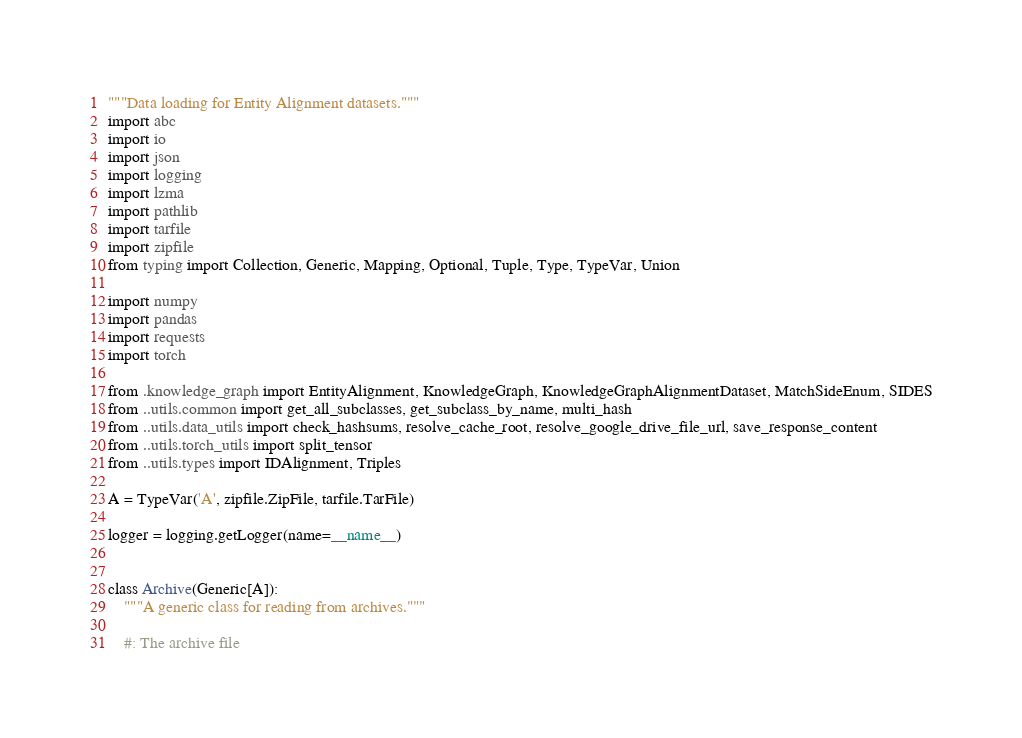Convert code to text. <code><loc_0><loc_0><loc_500><loc_500><_Python_>"""Data loading for Entity Alignment datasets."""
import abc
import io
import json
import logging
import lzma
import pathlib
import tarfile
import zipfile
from typing import Collection, Generic, Mapping, Optional, Tuple, Type, TypeVar, Union

import numpy
import pandas
import requests
import torch

from .knowledge_graph import EntityAlignment, KnowledgeGraph, KnowledgeGraphAlignmentDataset, MatchSideEnum, SIDES
from ..utils.common import get_all_subclasses, get_subclass_by_name, multi_hash
from ..utils.data_utils import check_hashsums, resolve_cache_root, resolve_google_drive_file_url, save_response_content
from ..utils.torch_utils import split_tensor
from ..utils.types import IDAlignment, Triples

A = TypeVar('A', zipfile.ZipFile, tarfile.TarFile)

logger = logging.getLogger(name=__name__)


class Archive(Generic[A]):
    """A generic class for reading from archives."""

    #: The archive file</code> 